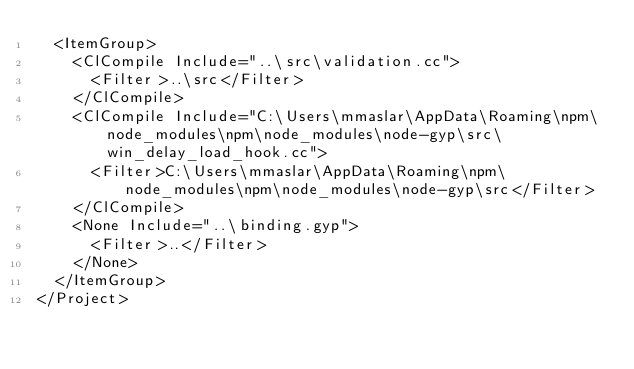Convert code to text. <code><loc_0><loc_0><loc_500><loc_500><_XML_>  <ItemGroup>
    <ClCompile Include="..\src\validation.cc">
      <Filter>..\src</Filter>
    </ClCompile>
    <ClCompile Include="C:\Users\mmaslar\AppData\Roaming\npm\node_modules\npm\node_modules\node-gyp\src\win_delay_load_hook.cc">
      <Filter>C:\Users\mmaslar\AppData\Roaming\npm\node_modules\npm\node_modules\node-gyp\src</Filter>
    </ClCompile>
    <None Include="..\binding.gyp">
      <Filter>..</Filter>
    </None>
  </ItemGroup>
</Project>
</code> 